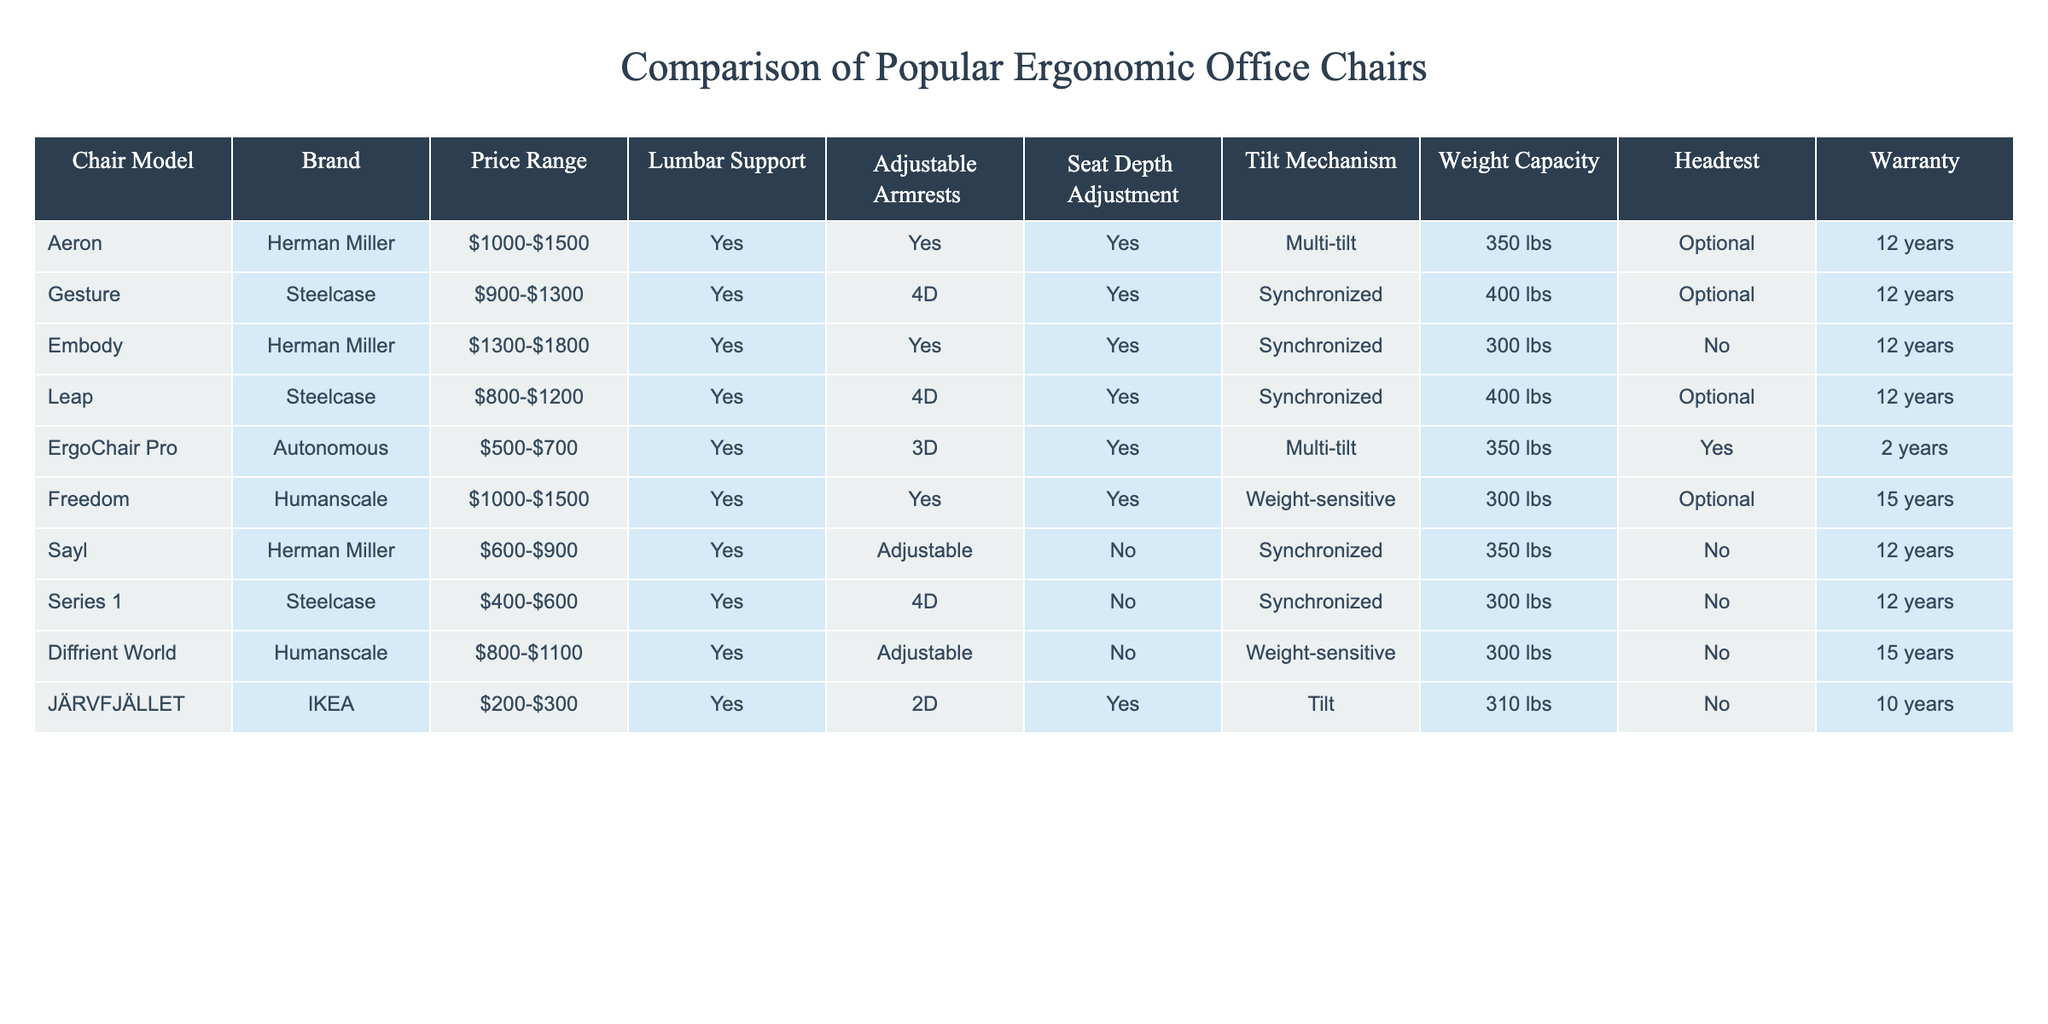What is the price range of the Aeron chair? The price range of the Aeron chair is explicitly listed in the table as "$1000-$1500".
Answer: $1000-$1500 Which chairs have a weight capacity of 400 lbs? The tables indicate that both the Gesture and Leap chairs have a weight capacity of 400 lbs.
Answer: Gesture, Leap Is there a chair with both adjustable armrests and a headrest? The ErgoChair Pro has adjustable armrests and also comes with a headrest, fulfilling both conditions.
Answer: Yes What is the warranty period of the Freedom chair? The warranty period for the Freedom chair is stated in the table as 15 years.
Answer: 15 years How many chairs have a lumbar support feature and a synchronized tilt mechanism? By reviewing the table, we can see that the Aeron, Gesture, Embody, Leap, Freedom, and Sayl chairs all provide both lumbar support and a synchronized tilt mechanism. Counting these gives a total of six chairs.
Answer: 6 Which chair is the least expensive option that includes adjustable armrests? Analyzing the table, we find that the Series 1 chair, costing between $400-$600, is the least expensive and still features adjustable armrests.
Answer: Series 1 What is the average price range of the chairs listed in the table? The price ranges are $1000-$1500, $900-$1300, $1300-$1800, $800-$1200, $500-$700, $1000-$1500, $600-$900, $400-$600, $800-$1100, and $200-$300. By averaging the high and low ends of these price ranges: (1500 + 1300 + 1800 + 1200 + 700 + 1500 + 900 + 600 + 1100 + 300) / 10 = $1040. The average low end is (1000 + 900 + 1300 + 800 + 500 + 1000 + 600 + 400 + 800 + 200) / 10 = $720. Thus, the average price range is approximately $720-$1040.
Answer: $720-$1040 Which chair has the most extended warranty period, and how long is it? Reviewing the warranty column in the table, the Freedom chair has the longest warranty period of 15 years compared to all other chairs listed.
Answer: Freedom, 15 years How many chairs do not come with a headrest? Looking at the table, we can identify that the Embody, Sayl, and Diffrient World chairs do not include a headrest. There are three such chairs.
Answer: 3 